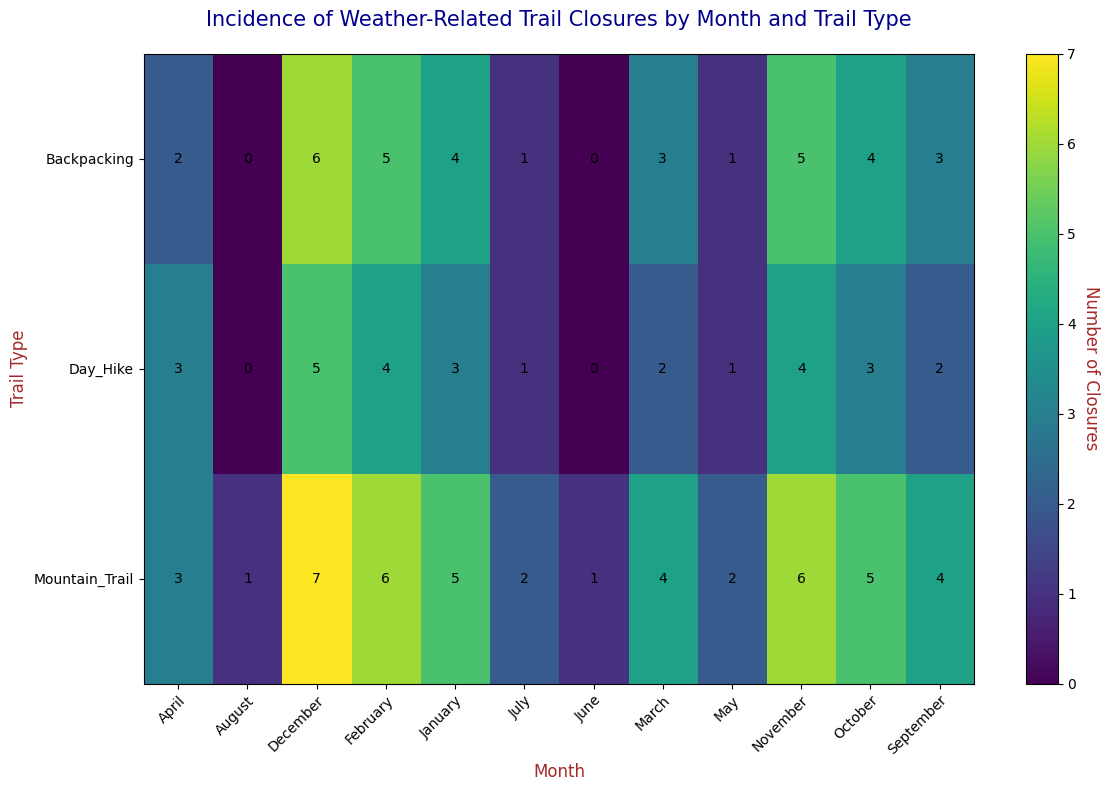Which trail type has the highest number of closures in December? By observing the heatmap, the cell with the highest value in December across all trail types is marked. The Mountain_Trail has the cell with the highest value (7).
Answer: Mountain_Trail What is the total number of closures for Day Hike trails throughout the year? Sum the values for each month under the Day_Hike row. The values are 3, 4, 2, 3, 1, 0, 1, 0, 2, 3, 4, 5. So, the sum is 28.
Answer: 28 In which month do Backpacking trails have the fewest closures? Scan the Backpacking row for the smallest value. The smallest value is 0, occurring in June and August.
Answer: June and August During which month do we see the highest number of total closures across all three trail types? Add up the values across all trail types for each month and compare. December has 5 (Day_Hike) + 6 (Backpacking) + 7 (Mountain_Trail) = 18, which is the highest.
Answer: December On average, how many closures do Mountain Trail types experience per month? Sum the closures for Mountain_Trail: 5, 6, 4, 3, 2, 1, 2, 1, 4, 5, 6, 7, resulting in 46. Divide by 12 (months). The average is 46 / 12 ≈ 3.83.
Answer: 3.83 Which trail type consistently shows lower closures in the summer months (June, July, August)? Compare June, July, and August for each trail type. Day_Hike has closures of 0, 1, 0; Backpacking has closures of 0, 1, 0; Mountain_Trail has closures of 1, 2, 1. Both Day_Hike and Backpacking have consistently lower closures (1 or 0).
Answer: Day_Hike and Backpacking Are there any months where all trail types experience closures, and if so, which ones? Check for each month where all three trail types have non-zero values. All months have non-zero values, indicating closures throughout the year.
Answer: All months Do Mountain Trail closures exhibit any patterns over the year? Examine the closures month by month for Mountain_Trail. The values rise steadily from January (5) to December (7) with some fluctuations peaking in the colder months.
Answer: Yes, higher in winter months 